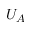Convert formula to latex. <formula><loc_0><loc_0><loc_500><loc_500>U _ { A }</formula> 